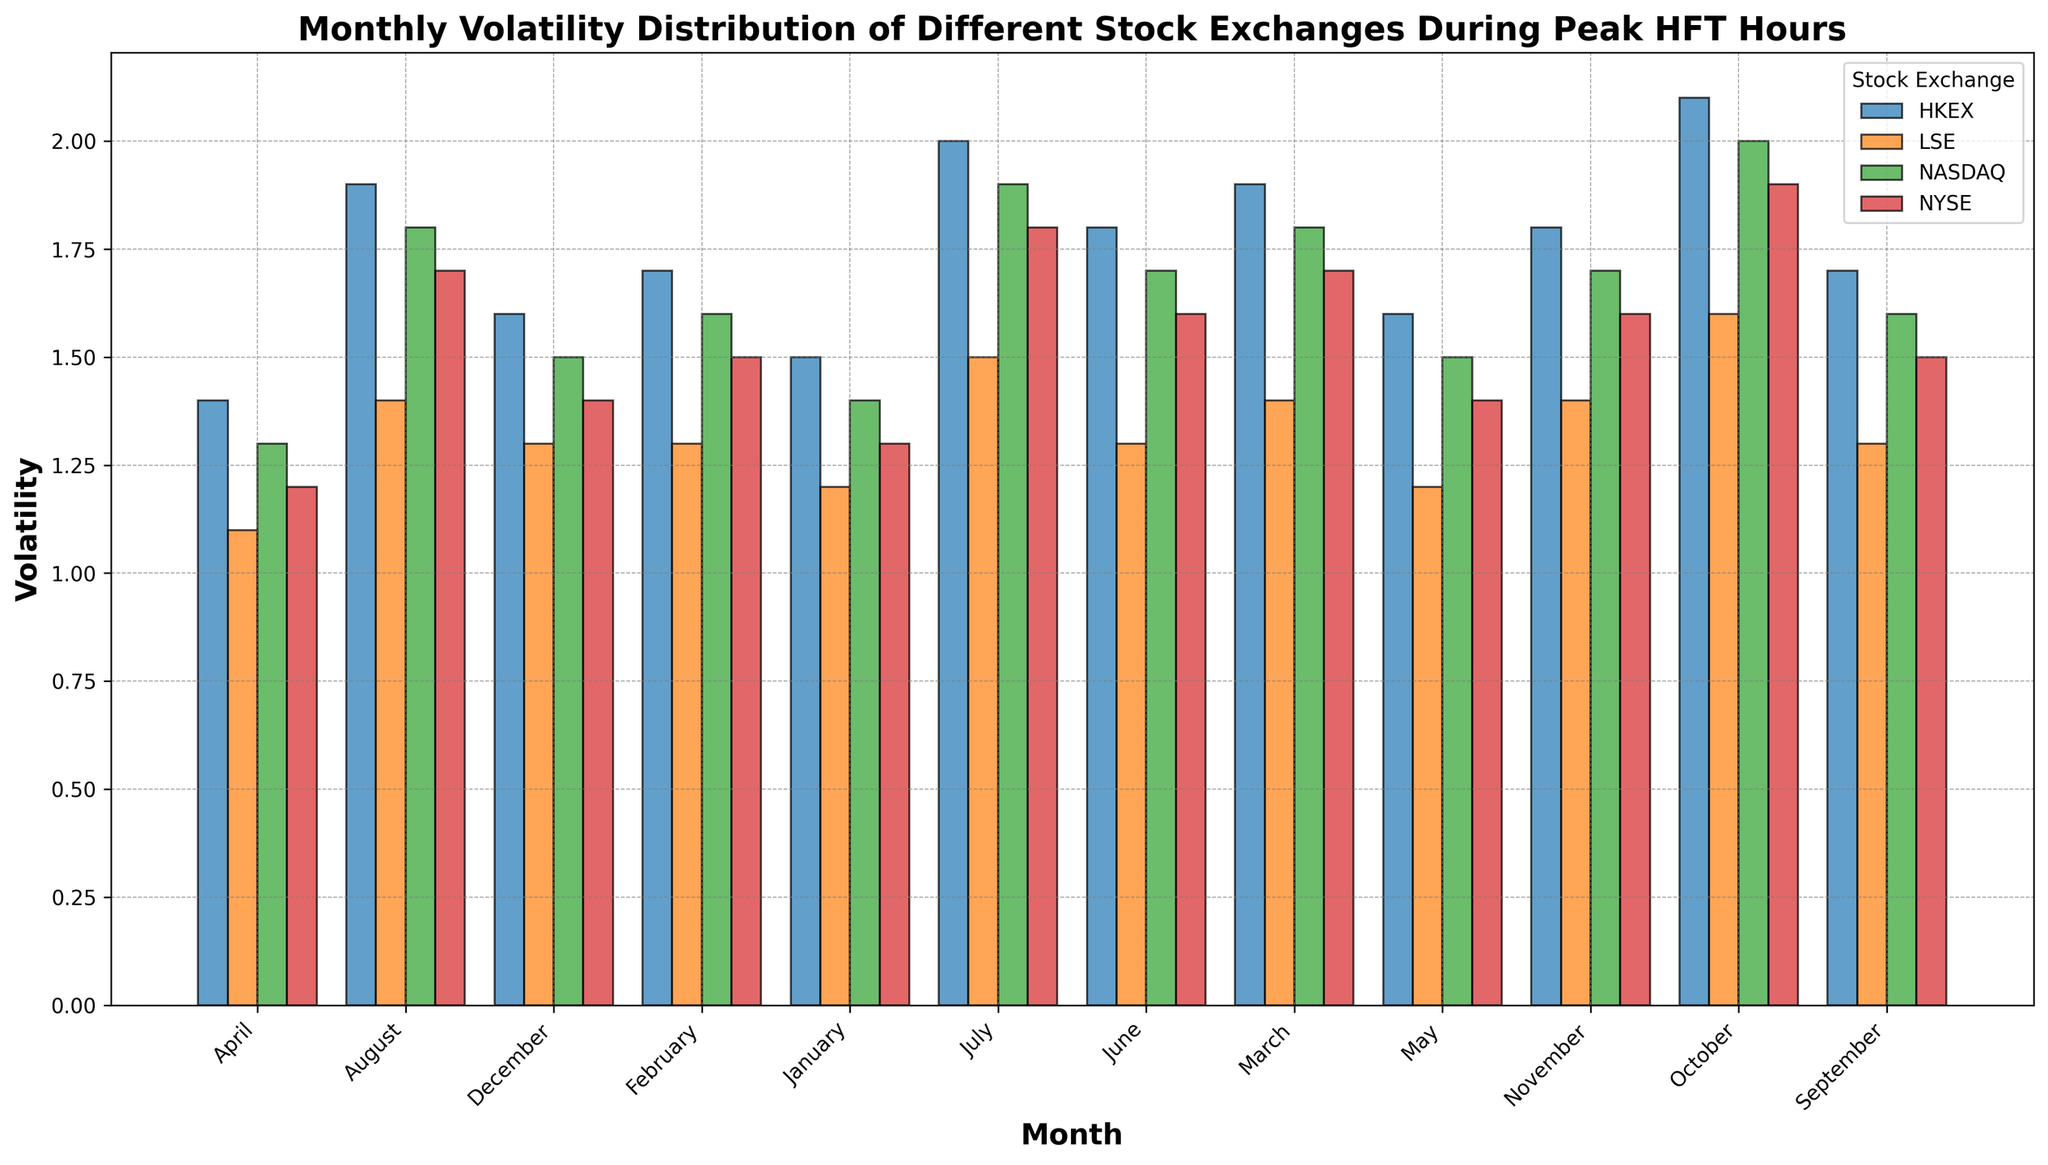What is the volatility for NASDAQ in July? Find NASDAQ on the legend, locate the bar for July, and read the height of the bar for NASDAQ in that month, which corresponds to the volatility.
Answer: 1.9 Which stock exchange exhibits the highest volatility in October? Compare the heights of the bars for each exchange in October. The highest bar corresponds to the HKEX.
Answer: HKEX During which month does NYSE have the lowest volatility? Look for the shortest bar for NYSE, check the x-axis label for that bar to identify the month.
Answer: April Compare the overall average volatility for NASDAQ and NYSE across the year. Calculate the average by summing the monthly volatility values for each exchange and dividing by the number of months (12). For NASDAQ: (1.4+1.6+1.8+1.3+1.5+1.7+1.9+1.8+1.6+2.0+1.7+1.5)/12. For NYSE: (1.3+1.5+1.7+1.2+1.4+1.6+1.8+1.7+1.5+1.9+1.6+1.4)/12.
Answer: NASDAQ: 1.6667, NYSE: 1.5667 Between which months does HKEX experience the largest increase in volatility? Observe the bars for HKEX month by month, identify the months between which there is the largest increase in height. The largest increase is between September and October (1.7 to 2.1).
Answer: September to October In which month is the volatility the same for LSE and NASDAQ? Check each month, looking for bars of equal height for LSE and NASDAQ. For May, both exchanges have a volatility of 1.5.
Answer: May Which stock exchange shows the most variability in its monthly volatility over the year? Look for the stock exchange with the largest range between its lowest and highest monthly volatility values. Compare the maximum and minimum values for each exchange. HKEX fluctuates from 1.4 to 2.1, which is the largest range (0.7).
Answer: HKEX Is there any month where all exchanges have volatility greater than 1.5? Examine each month, ensuring that every bar in that month is above the 1.5 mark. In October, all exchanges (NYSE, NASDAQ, LSE, and HKEX) have volatility greater than 1.5.
Answer: October 